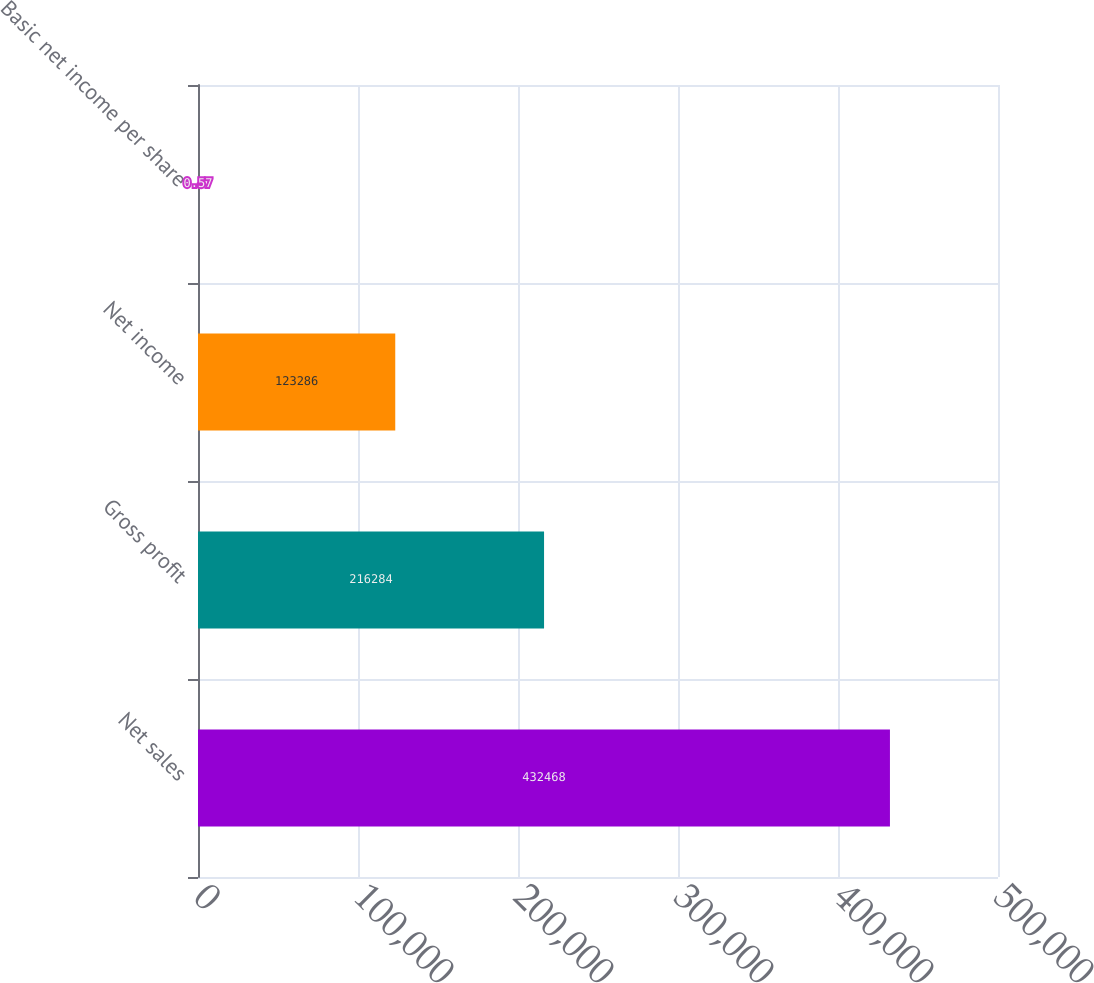<chart> <loc_0><loc_0><loc_500><loc_500><bar_chart><fcel>Net sales<fcel>Gross profit<fcel>Net income<fcel>Basic net income per share<nl><fcel>432468<fcel>216284<fcel>123286<fcel>0.57<nl></chart> 